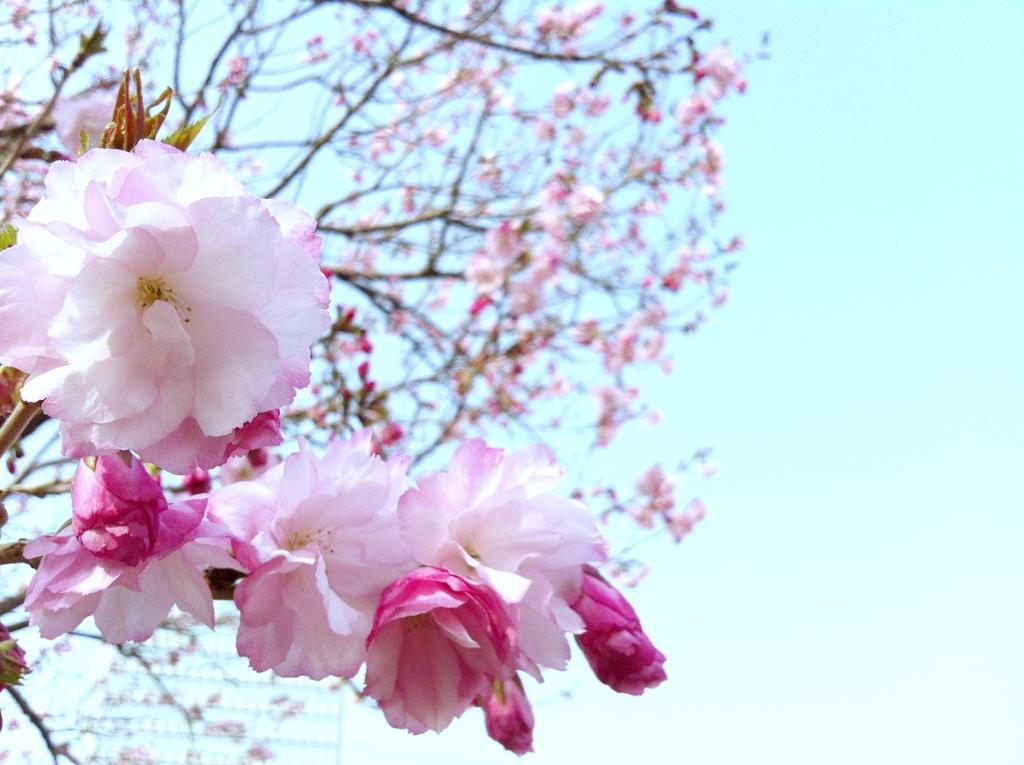What type of plants can be seen in the image? There are flowers in the image. What other natural element is present in the image? There is a tree in the image. What type of frame is visible around the moon in the image? There is no moon present in the image, and therefore no frame around it. Who is the porter in the image? There is no porter present in the image. 